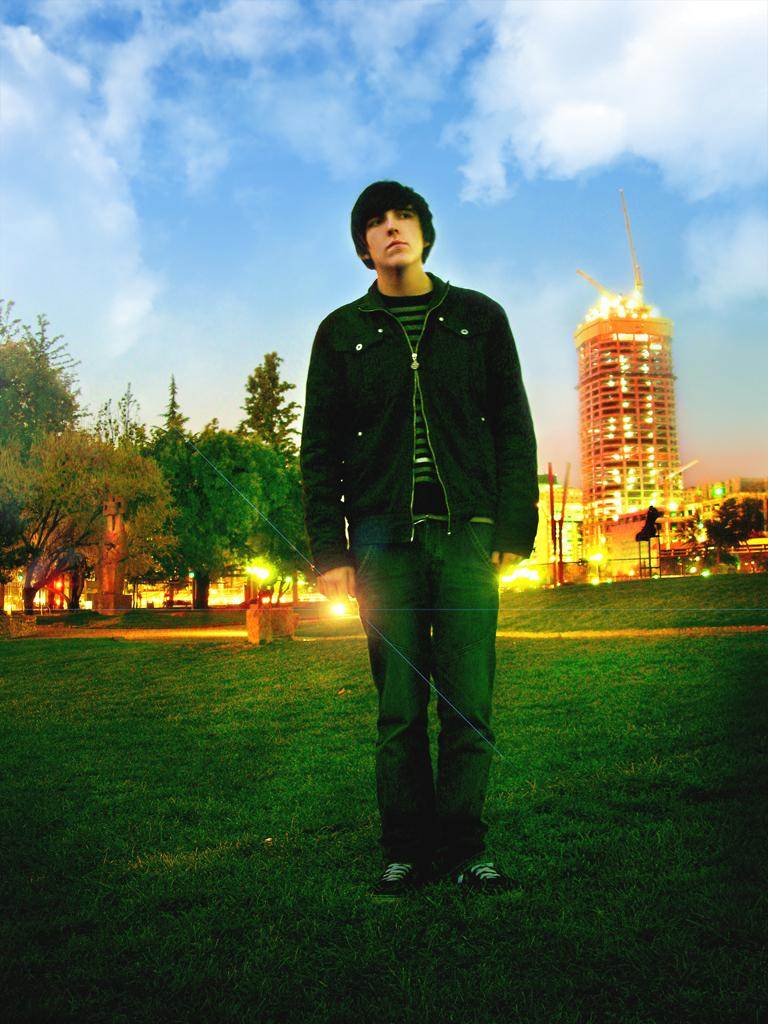Who is the main subject in the image? There is a boy in the image. What is the boy wearing? The boy is wearing a black jacket. Where is the boy standing? The boy is standing on a green lawn. What is the boy doing in the image? The boy is posing for the camera. What can be seen in the background of the image? There are trees and a building visible in the background. Can you tell me how many basketballs are visible in the image? There are no basketballs present in the image. What type of wall can be seen behind the boy in the image? There is no wall visible in the image; it features a green lawn and a background with trees and a building. 